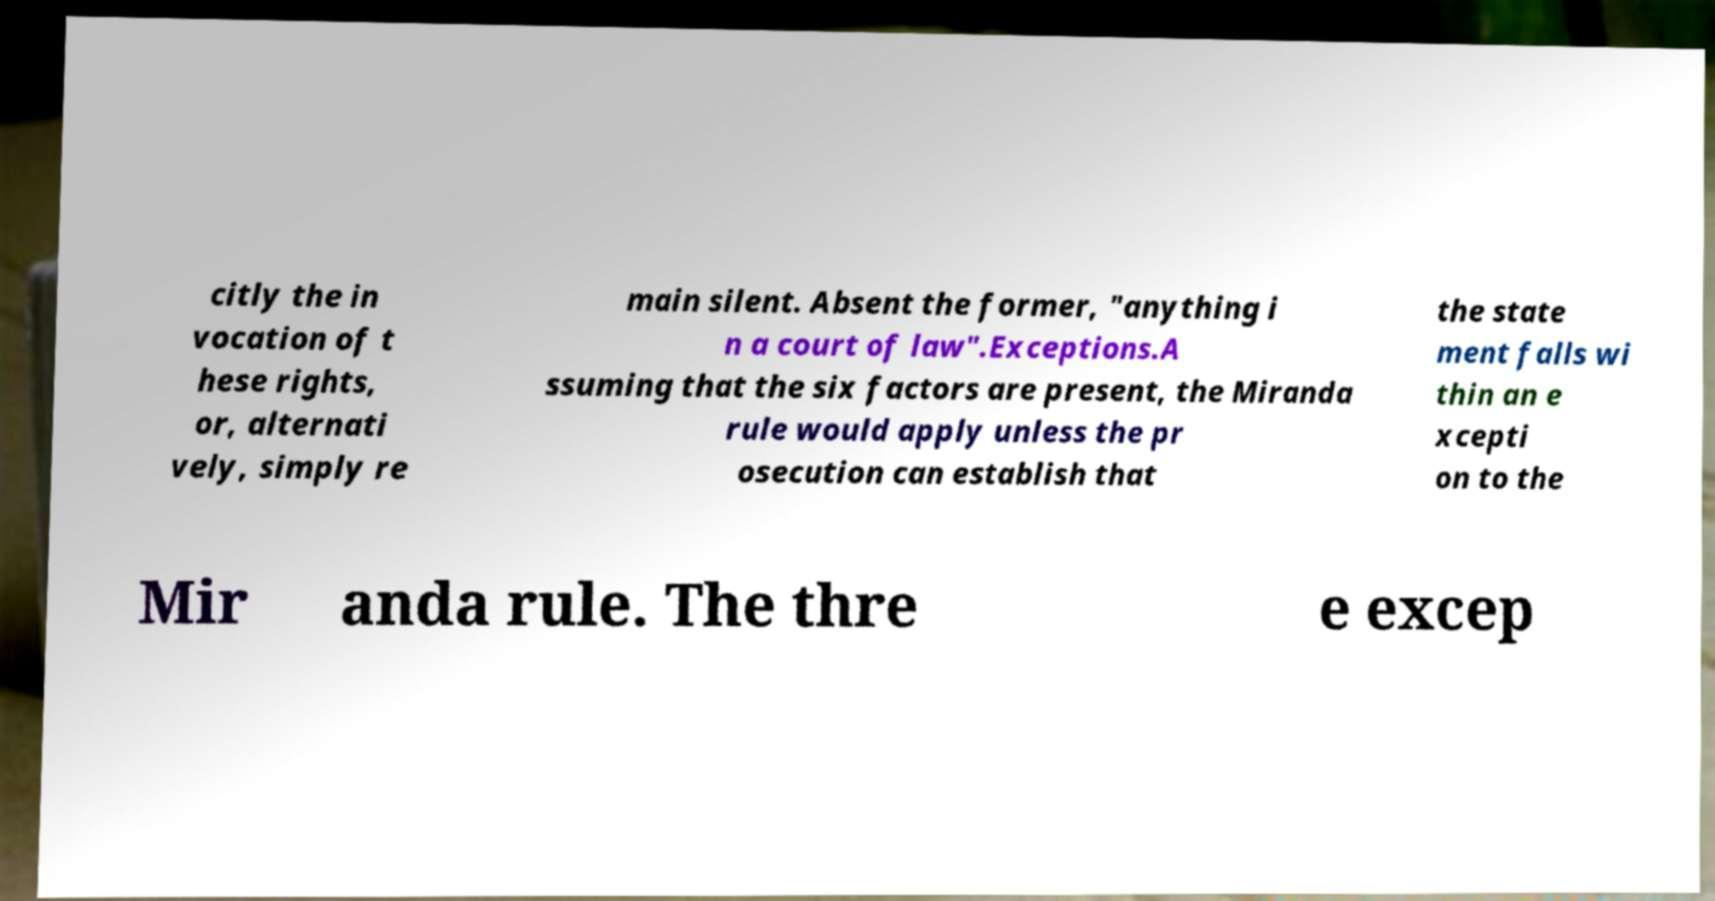Could you assist in decoding the text presented in this image and type it out clearly? citly the in vocation of t hese rights, or, alternati vely, simply re main silent. Absent the former, "anything i n a court of law".Exceptions.A ssuming that the six factors are present, the Miranda rule would apply unless the pr osecution can establish that the state ment falls wi thin an e xcepti on to the Mir anda rule. The thre e excep 